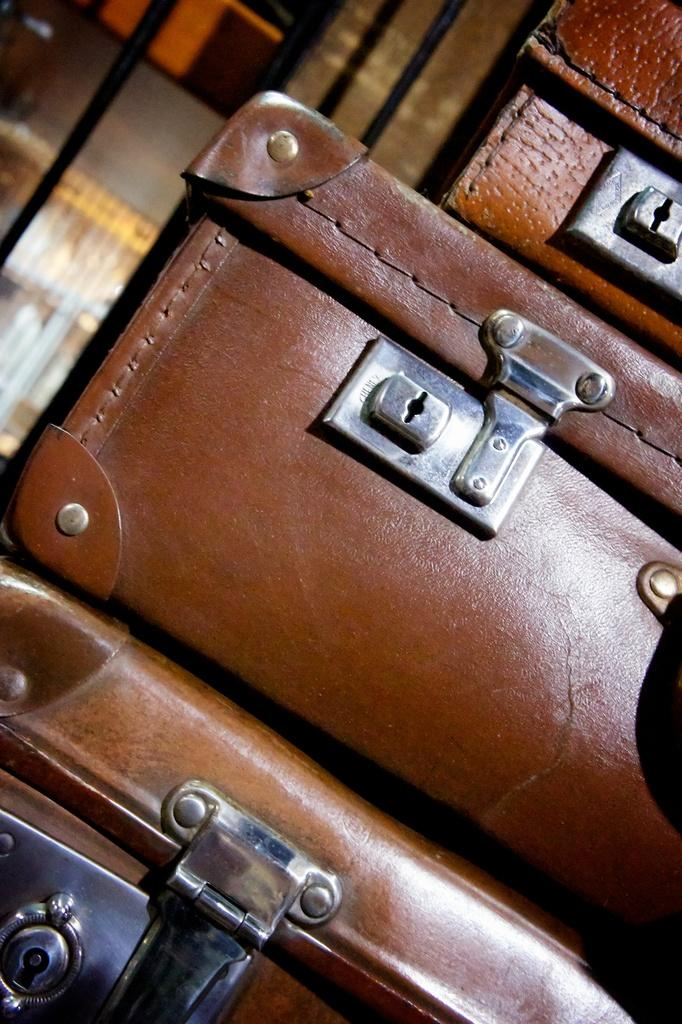What can be seen in the image? There is an object in the image. Can you describe the color of the object? The object is brown in color. How many bubbles are floating around the brown object in the image? There are no bubbles present in the image. 